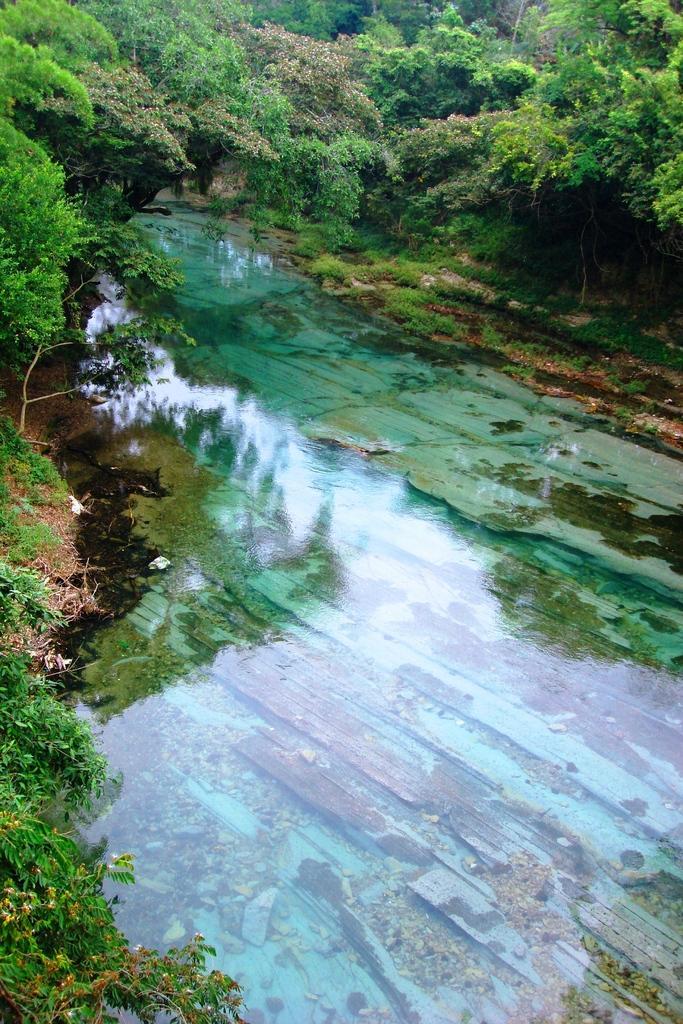In one or two sentences, can you explain what this image depicts? In the center of the image we can see a pond. On the right side of the image there are trees. On the left side of the image we can see trees. 